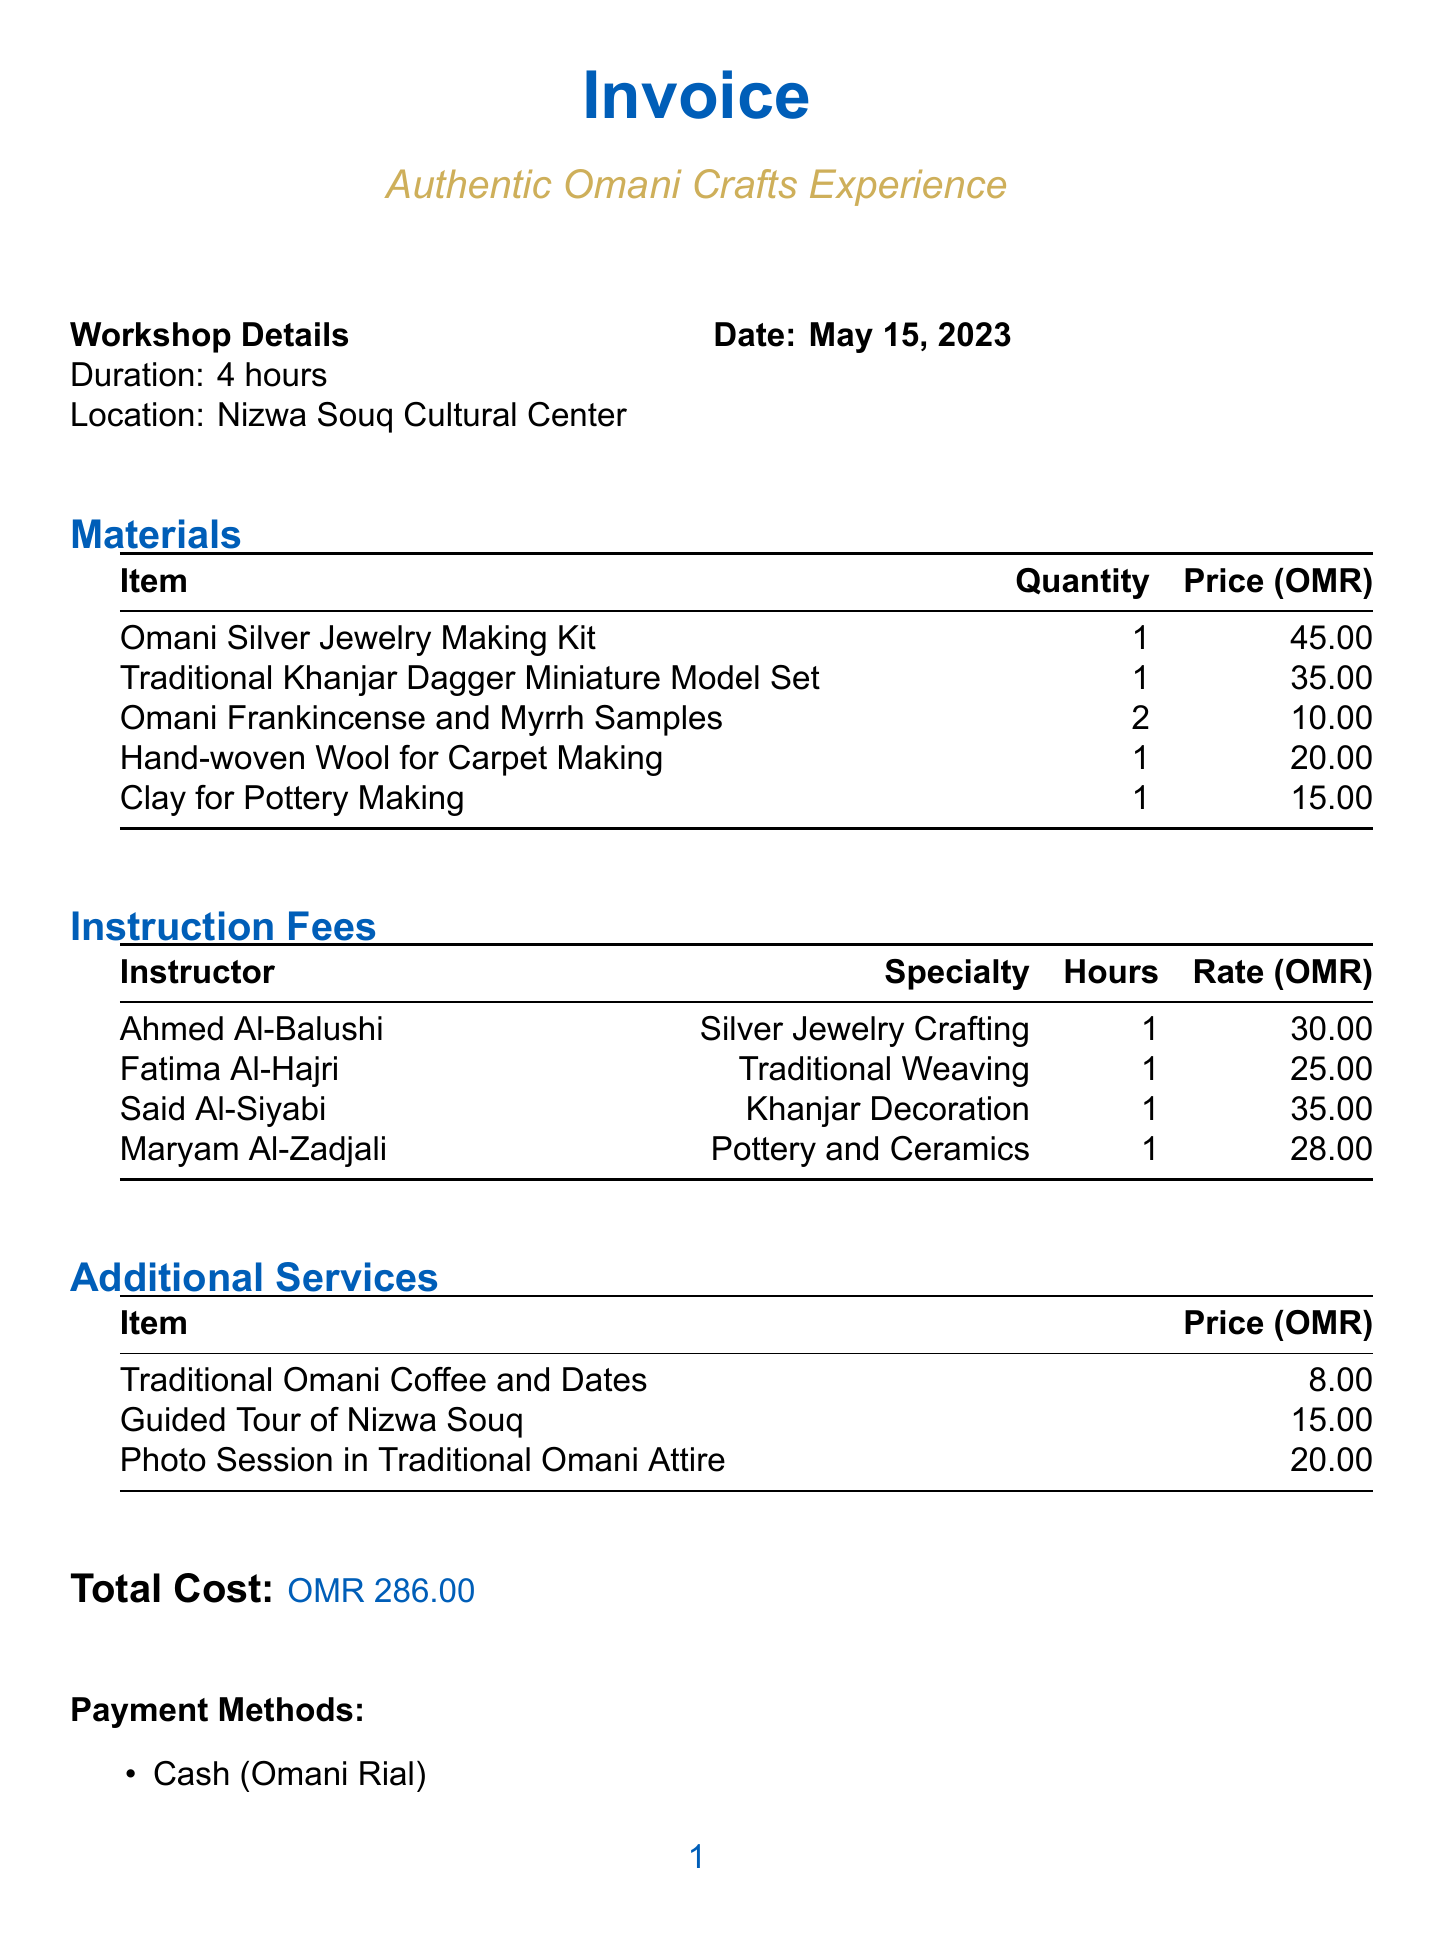What is the workshop name? The workshop name is stated clearly in the document as part of the invoice details.
Answer: Authentic Omani Crafts Experience What is the duration of the workshop? The duration of the workshop is explicitly mentioned in the invoice details section.
Answer: 4 hours Where is the workshop located? The location of the workshop is given in the invoice details section.
Answer: Nizwa Souq Cultural Center Who is the instructor for Silver Jewelry Crafting? The instructor's name for Silver Jewelry Crafting is listed under the instruction fees.
Answer: Ahmed Al-Balushi What is the price of the Omani Silver Jewelry Making Kit? The price can be found in the materials section of the document.
Answer: 45.00 What is the total cost? The total cost is provided at the end of the invoice.
Answer: OMR 286.00 How many instructors are listed in the document? The number of instructors can be determined by counting the entries in the instruction fees section.
Answer: 4 What is the cancellation policy for the workshop? The cancellation policy is summarized at the end of the document.
Answer: Full refund if cancelled 48 hours before the workshop What additional service costs 20.00? The additional services are detailed, allowing for identification of the specific item by its cost.
Answer: Photo Session in Traditional Omani Attire 